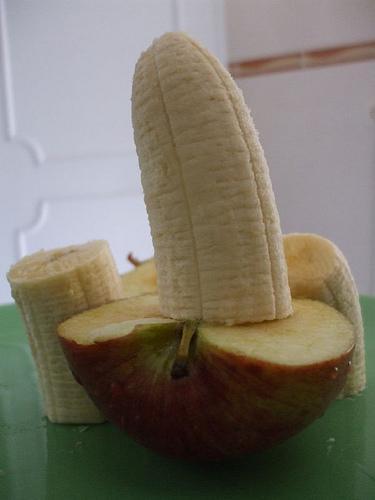How many pieces are apple are there?
Give a very brief answer. 1. How many pieces of banana are there?
Give a very brief answer. 3. How many bananas can be seen?
Give a very brief answer. 3. 